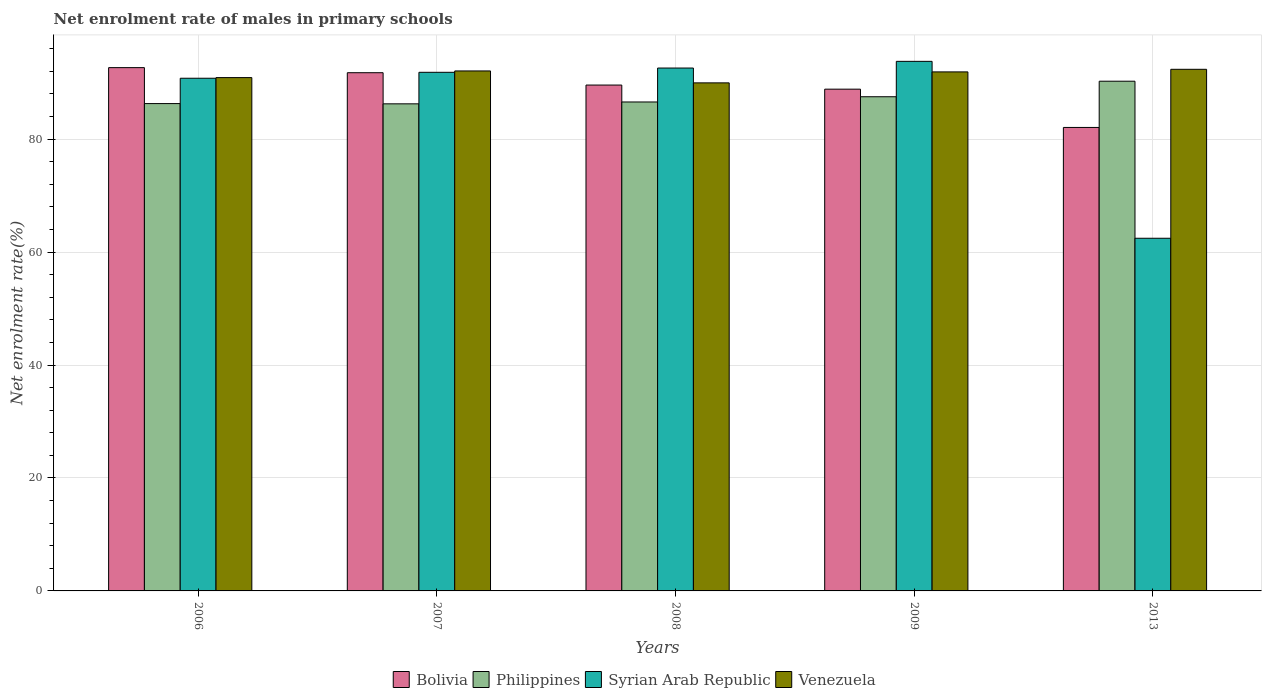How many different coloured bars are there?
Offer a very short reply. 4. How many bars are there on the 5th tick from the left?
Make the answer very short. 4. What is the net enrolment rate of males in primary schools in Bolivia in 2013?
Your answer should be compact. 82.07. Across all years, what is the maximum net enrolment rate of males in primary schools in Syrian Arab Republic?
Ensure brevity in your answer.  93.77. Across all years, what is the minimum net enrolment rate of males in primary schools in Bolivia?
Make the answer very short. 82.07. In which year was the net enrolment rate of males in primary schools in Syrian Arab Republic maximum?
Offer a terse response. 2009. In which year was the net enrolment rate of males in primary schools in Bolivia minimum?
Your response must be concise. 2013. What is the total net enrolment rate of males in primary schools in Philippines in the graph?
Provide a succinct answer. 436.88. What is the difference between the net enrolment rate of males in primary schools in Syrian Arab Republic in 2008 and that in 2013?
Your answer should be very brief. 30.14. What is the difference between the net enrolment rate of males in primary schools in Bolivia in 2006 and the net enrolment rate of males in primary schools in Philippines in 2013?
Give a very brief answer. 2.41. What is the average net enrolment rate of males in primary schools in Philippines per year?
Provide a succinct answer. 87.38. In the year 2006, what is the difference between the net enrolment rate of males in primary schools in Syrian Arab Republic and net enrolment rate of males in primary schools in Philippines?
Keep it short and to the point. 4.49. In how many years, is the net enrolment rate of males in primary schools in Philippines greater than 44 %?
Provide a succinct answer. 5. What is the ratio of the net enrolment rate of males in primary schools in Venezuela in 2006 to that in 2008?
Provide a succinct answer. 1.01. What is the difference between the highest and the second highest net enrolment rate of males in primary schools in Syrian Arab Republic?
Give a very brief answer. 1.18. What is the difference between the highest and the lowest net enrolment rate of males in primary schools in Syrian Arab Republic?
Offer a terse response. 31.32. In how many years, is the net enrolment rate of males in primary schools in Philippines greater than the average net enrolment rate of males in primary schools in Philippines taken over all years?
Your answer should be compact. 2. What does the 3rd bar from the left in 2007 represents?
Give a very brief answer. Syrian Arab Republic. What does the 3rd bar from the right in 2013 represents?
Your answer should be compact. Philippines. Is it the case that in every year, the sum of the net enrolment rate of males in primary schools in Philippines and net enrolment rate of males in primary schools in Venezuela is greater than the net enrolment rate of males in primary schools in Syrian Arab Republic?
Provide a succinct answer. Yes. How many bars are there?
Your answer should be compact. 20. Are all the bars in the graph horizontal?
Offer a very short reply. No. What is the difference between two consecutive major ticks on the Y-axis?
Provide a short and direct response. 20. Are the values on the major ticks of Y-axis written in scientific E-notation?
Give a very brief answer. No. Does the graph contain grids?
Make the answer very short. Yes. How many legend labels are there?
Offer a very short reply. 4. What is the title of the graph?
Make the answer very short. Net enrolment rate of males in primary schools. What is the label or title of the X-axis?
Make the answer very short. Years. What is the label or title of the Y-axis?
Give a very brief answer. Net enrolment rate(%). What is the Net enrolment rate(%) in Bolivia in 2006?
Your answer should be very brief. 92.66. What is the Net enrolment rate(%) of Philippines in 2006?
Your response must be concise. 86.29. What is the Net enrolment rate(%) in Syrian Arab Republic in 2006?
Ensure brevity in your answer.  90.78. What is the Net enrolment rate(%) of Venezuela in 2006?
Provide a short and direct response. 90.89. What is the Net enrolment rate(%) in Bolivia in 2007?
Provide a short and direct response. 91.76. What is the Net enrolment rate(%) in Philippines in 2007?
Your answer should be compact. 86.25. What is the Net enrolment rate(%) of Syrian Arab Republic in 2007?
Give a very brief answer. 91.83. What is the Net enrolment rate(%) of Venezuela in 2007?
Provide a short and direct response. 92.07. What is the Net enrolment rate(%) of Bolivia in 2008?
Keep it short and to the point. 89.57. What is the Net enrolment rate(%) of Philippines in 2008?
Give a very brief answer. 86.58. What is the Net enrolment rate(%) of Syrian Arab Republic in 2008?
Provide a short and direct response. 92.59. What is the Net enrolment rate(%) in Venezuela in 2008?
Your answer should be very brief. 89.96. What is the Net enrolment rate(%) in Bolivia in 2009?
Provide a succinct answer. 88.85. What is the Net enrolment rate(%) of Philippines in 2009?
Make the answer very short. 87.5. What is the Net enrolment rate(%) of Syrian Arab Republic in 2009?
Provide a succinct answer. 93.77. What is the Net enrolment rate(%) of Venezuela in 2009?
Your answer should be very brief. 91.9. What is the Net enrolment rate(%) of Bolivia in 2013?
Your answer should be very brief. 82.07. What is the Net enrolment rate(%) of Philippines in 2013?
Provide a succinct answer. 90.25. What is the Net enrolment rate(%) of Syrian Arab Republic in 2013?
Your answer should be compact. 62.45. What is the Net enrolment rate(%) in Venezuela in 2013?
Make the answer very short. 92.36. Across all years, what is the maximum Net enrolment rate(%) of Bolivia?
Make the answer very short. 92.66. Across all years, what is the maximum Net enrolment rate(%) in Philippines?
Make the answer very short. 90.25. Across all years, what is the maximum Net enrolment rate(%) in Syrian Arab Republic?
Provide a short and direct response. 93.77. Across all years, what is the maximum Net enrolment rate(%) of Venezuela?
Your response must be concise. 92.36. Across all years, what is the minimum Net enrolment rate(%) in Bolivia?
Make the answer very short. 82.07. Across all years, what is the minimum Net enrolment rate(%) in Philippines?
Your answer should be compact. 86.25. Across all years, what is the minimum Net enrolment rate(%) of Syrian Arab Republic?
Provide a short and direct response. 62.45. Across all years, what is the minimum Net enrolment rate(%) of Venezuela?
Your response must be concise. 89.96. What is the total Net enrolment rate(%) in Bolivia in the graph?
Provide a succinct answer. 444.9. What is the total Net enrolment rate(%) of Philippines in the graph?
Ensure brevity in your answer.  436.88. What is the total Net enrolment rate(%) of Syrian Arab Republic in the graph?
Ensure brevity in your answer.  431.42. What is the total Net enrolment rate(%) in Venezuela in the graph?
Ensure brevity in your answer.  457.19. What is the difference between the Net enrolment rate(%) in Bolivia in 2006 and that in 2007?
Offer a very short reply. 0.9. What is the difference between the Net enrolment rate(%) of Philippines in 2006 and that in 2007?
Your answer should be very brief. 0.04. What is the difference between the Net enrolment rate(%) in Syrian Arab Republic in 2006 and that in 2007?
Your answer should be compact. -1.05. What is the difference between the Net enrolment rate(%) in Venezuela in 2006 and that in 2007?
Offer a terse response. -1.18. What is the difference between the Net enrolment rate(%) of Bolivia in 2006 and that in 2008?
Make the answer very short. 3.08. What is the difference between the Net enrolment rate(%) in Philippines in 2006 and that in 2008?
Ensure brevity in your answer.  -0.29. What is the difference between the Net enrolment rate(%) of Syrian Arab Republic in 2006 and that in 2008?
Your answer should be very brief. -1.81. What is the difference between the Net enrolment rate(%) in Venezuela in 2006 and that in 2008?
Give a very brief answer. 0.93. What is the difference between the Net enrolment rate(%) in Bolivia in 2006 and that in 2009?
Provide a succinct answer. 3.81. What is the difference between the Net enrolment rate(%) in Philippines in 2006 and that in 2009?
Offer a terse response. -1.21. What is the difference between the Net enrolment rate(%) of Syrian Arab Republic in 2006 and that in 2009?
Provide a succinct answer. -2.99. What is the difference between the Net enrolment rate(%) of Venezuela in 2006 and that in 2009?
Your answer should be compact. -1.01. What is the difference between the Net enrolment rate(%) of Bolivia in 2006 and that in 2013?
Your answer should be very brief. 10.59. What is the difference between the Net enrolment rate(%) in Philippines in 2006 and that in 2013?
Your response must be concise. -3.96. What is the difference between the Net enrolment rate(%) of Syrian Arab Republic in 2006 and that in 2013?
Your answer should be compact. 28.33. What is the difference between the Net enrolment rate(%) in Venezuela in 2006 and that in 2013?
Offer a very short reply. -1.47. What is the difference between the Net enrolment rate(%) of Bolivia in 2007 and that in 2008?
Your response must be concise. 2.18. What is the difference between the Net enrolment rate(%) of Philippines in 2007 and that in 2008?
Provide a short and direct response. -0.33. What is the difference between the Net enrolment rate(%) in Syrian Arab Republic in 2007 and that in 2008?
Your response must be concise. -0.76. What is the difference between the Net enrolment rate(%) in Venezuela in 2007 and that in 2008?
Your response must be concise. 2.11. What is the difference between the Net enrolment rate(%) of Bolivia in 2007 and that in 2009?
Offer a very short reply. 2.91. What is the difference between the Net enrolment rate(%) of Philippines in 2007 and that in 2009?
Provide a short and direct response. -1.26. What is the difference between the Net enrolment rate(%) in Syrian Arab Republic in 2007 and that in 2009?
Your response must be concise. -1.94. What is the difference between the Net enrolment rate(%) of Venezuela in 2007 and that in 2009?
Offer a terse response. 0.17. What is the difference between the Net enrolment rate(%) in Bolivia in 2007 and that in 2013?
Your answer should be very brief. 9.69. What is the difference between the Net enrolment rate(%) in Philippines in 2007 and that in 2013?
Provide a succinct answer. -4. What is the difference between the Net enrolment rate(%) in Syrian Arab Republic in 2007 and that in 2013?
Ensure brevity in your answer.  29.39. What is the difference between the Net enrolment rate(%) of Venezuela in 2007 and that in 2013?
Keep it short and to the point. -0.29. What is the difference between the Net enrolment rate(%) in Bolivia in 2008 and that in 2009?
Ensure brevity in your answer.  0.73. What is the difference between the Net enrolment rate(%) of Philippines in 2008 and that in 2009?
Your answer should be compact. -0.93. What is the difference between the Net enrolment rate(%) of Syrian Arab Republic in 2008 and that in 2009?
Give a very brief answer. -1.18. What is the difference between the Net enrolment rate(%) in Venezuela in 2008 and that in 2009?
Offer a very short reply. -1.94. What is the difference between the Net enrolment rate(%) in Bolivia in 2008 and that in 2013?
Keep it short and to the point. 7.51. What is the difference between the Net enrolment rate(%) of Philippines in 2008 and that in 2013?
Make the answer very short. -3.68. What is the difference between the Net enrolment rate(%) in Syrian Arab Republic in 2008 and that in 2013?
Keep it short and to the point. 30.14. What is the difference between the Net enrolment rate(%) in Venezuela in 2008 and that in 2013?
Provide a succinct answer. -2.4. What is the difference between the Net enrolment rate(%) of Bolivia in 2009 and that in 2013?
Your answer should be very brief. 6.78. What is the difference between the Net enrolment rate(%) in Philippines in 2009 and that in 2013?
Ensure brevity in your answer.  -2.75. What is the difference between the Net enrolment rate(%) in Syrian Arab Republic in 2009 and that in 2013?
Provide a succinct answer. 31.32. What is the difference between the Net enrolment rate(%) of Venezuela in 2009 and that in 2013?
Your response must be concise. -0.46. What is the difference between the Net enrolment rate(%) of Bolivia in 2006 and the Net enrolment rate(%) of Philippines in 2007?
Your response must be concise. 6.41. What is the difference between the Net enrolment rate(%) in Bolivia in 2006 and the Net enrolment rate(%) in Syrian Arab Republic in 2007?
Your answer should be very brief. 0.83. What is the difference between the Net enrolment rate(%) in Bolivia in 2006 and the Net enrolment rate(%) in Venezuela in 2007?
Give a very brief answer. 0.59. What is the difference between the Net enrolment rate(%) of Philippines in 2006 and the Net enrolment rate(%) of Syrian Arab Republic in 2007?
Ensure brevity in your answer.  -5.54. What is the difference between the Net enrolment rate(%) of Philippines in 2006 and the Net enrolment rate(%) of Venezuela in 2007?
Offer a terse response. -5.78. What is the difference between the Net enrolment rate(%) of Syrian Arab Republic in 2006 and the Net enrolment rate(%) of Venezuela in 2007?
Provide a short and direct response. -1.29. What is the difference between the Net enrolment rate(%) in Bolivia in 2006 and the Net enrolment rate(%) in Philippines in 2008?
Your answer should be very brief. 6.08. What is the difference between the Net enrolment rate(%) in Bolivia in 2006 and the Net enrolment rate(%) in Syrian Arab Republic in 2008?
Your answer should be compact. 0.07. What is the difference between the Net enrolment rate(%) of Bolivia in 2006 and the Net enrolment rate(%) of Venezuela in 2008?
Provide a succinct answer. 2.7. What is the difference between the Net enrolment rate(%) of Philippines in 2006 and the Net enrolment rate(%) of Syrian Arab Republic in 2008?
Give a very brief answer. -6.3. What is the difference between the Net enrolment rate(%) of Philippines in 2006 and the Net enrolment rate(%) of Venezuela in 2008?
Your answer should be very brief. -3.67. What is the difference between the Net enrolment rate(%) in Syrian Arab Republic in 2006 and the Net enrolment rate(%) in Venezuela in 2008?
Ensure brevity in your answer.  0.82. What is the difference between the Net enrolment rate(%) of Bolivia in 2006 and the Net enrolment rate(%) of Philippines in 2009?
Your response must be concise. 5.15. What is the difference between the Net enrolment rate(%) of Bolivia in 2006 and the Net enrolment rate(%) of Syrian Arab Republic in 2009?
Provide a succinct answer. -1.11. What is the difference between the Net enrolment rate(%) of Bolivia in 2006 and the Net enrolment rate(%) of Venezuela in 2009?
Keep it short and to the point. 0.76. What is the difference between the Net enrolment rate(%) in Philippines in 2006 and the Net enrolment rate(%) in Syrian Arab Republic in 2009?
Give a very brief answer. -7.48. What is the difference between the Net enrolment rate(%) of Philippines in 2006 and the Net enrolment rate(%) of Venezuela in 2009?
Give a very brief answer. -5.61. What is the difference between the Net enrolment rate(%) of Syrian Arab Republic in 2006 and the Net enrolment rate(%) of Venezuela in 2009?
Ensure brevity in your answer.  -1.12. What is the difference between the Net enrolment rate(%) of Bolivia in 2006 and the Net enrolment rate(%) of Philippines in 2013?
Your answer should be very brief. 2.41. What is the difference between the Net enrolment rate(%) of Bolivia in 2006 and the Net enrolment rate(%) of Syrian Arab Republic in 2013?
Make the answer very short. 30.21. What is the difference between the Net enrolment rate(%) in Bolivia in 2006 and the Net enrolment rate(%) in Venezuela in 2013?
Your answer should be very brief. 0.29. What is the difference between the Net enrolment rate(%) in Philippines in 2006 and the Net enrolment rate(%) in Syrian Arab Republic in 2013?
Ensure brevity in your answer.  23.85. What is the difference between the Net enrolment rate(%) of Philippines in 2006 and the Net enrolment rate(%) of Venezuela in 2013?
Provide a short and direct response. -6.07. What is the difference between the Net enrolment rate(%) in Syrian Arab Republic in 2006 and the Net enrolment rate(%) in Venezuela in 2013?
Offer a very short reply. -1.58. What is the difference between the Net enrolment rate(%) in Bolivia in 2007 and the Net enrolment rate(%) in Philippines in 2008?
Provide a succinct answer. 5.18. What is the difference between the Net enrolment rate(%) of Bolivia in 2007 and the Net enrolment rate(%) of Syrian Arab Republic in 2008?
Offer a very short reply. -0.83. What is the difference between the Net enrolment rate(%) in Bolivia in 2007 and the Net enrolment rate(%) in Venezuela in 2008?
Offer a very short reply. 1.8. What is the difference between the Net enrolment rate(%) in Philippines in 2007 and the Net enrolment rate(%) in Syrian Arab Republic in 2008?
Keep it short and to the point. -6.34. What is the difference between the Net enrolment rate(%) in Philippines in 2007 and the Net enrolment rate(%) in Venezuela in 2008?
Make the answer very short. -3.71. What is the difference between the Net enrolment rate(%) of Syrian Arab Republic in 2007 and the Net enrolment rate(%) of Venezuela in 2008?
Provide a short and direct response. 1.87. What is the difference between the Net enrolment rate(%) of Bolivia in 2007 and the Net enrolment rate(%) of Philippines in 2009?
Keep it short and to the point. 4.25. What is the difference between the Net enrolment rate(%) in Bolivia in 2007 and the Net enrolment rate(%) in Syrian Arab Republic in 2009?
Give a very brief answer. -2.01. What is the difference between the Net enrolment rate(%) in Bolivia in 2007 and the Net enrolment rate(%) in Venezuela in 2009?
Provide a succinct answer. -0.14. What is the difference between the Net enrolment rate(%) of Philippines in 2007 and the Net enrolment rate(%) of Syrian Arab Republic in 2009?
Provide a short and direct response. -7.52. What is the difference between the Net enrolment rate(%) in Philippines in 2007 and the Net enrolment rate(%) in Venezuela in 2009?
Give a very brief answer. -5.65. What is the difference between the Net enrolment rate(%) of Syrian Arab Republic in 2007 and the Net enrolment rate(%) of Venezuela in 2009?
Give a very brief answer. -0.07. What is the difference between the Net enrolment rate(%) in Bolivia in 2007 and the Net enrolment rate(%) in Philippines in 2013?
Offer a terse response. 1.51. What is the difference between the Net enrolment rate(%) of Bolivia in 2007 and the Net enrolment rate(%) of Syrian Arab Republic in 2013?
Offer a very short reply. 29.31. What is the difference between the Net enrolment rate(%) in Bolivia in 2007 and the Net enrolment rate(%) in Venezuela in 2013?
Your answer should be very brief. -0.6. What is the difference between the Net enrolment rate(%) in Philippines in 2007 and the Net enrolment rate(%) in Syrian Arab Republic in 2013?
Your answer should be compact. 23.8. What is the difference between the Net enrolment rate(%) in Philippines in 2007 and the Net enrolment rate(%) in Venezuela in 2013?
Give a very brief answer. -6.11. What is the difference between the Net enrolment rate(%) in Syrian Arab Republic in 2007 and the Net enrolment rate(%) in Venezuela in 2013?
Offer a terse response. -0.53. What is the difference between the Net enrolment rate(%) in Bolivia in 2008 and the Net enrolment rate(%) in Philippines in 2009?
Provide a short and direct response. 2.07. What is the difference between the Net enrolment rate(%) of Bolivia in 2008 and the Net enrolment rate(%) of Syrian Arab Republic in 2009?
Keep it short and to the point. -4.2. What is the difference between the Net enrolment rate(%) in Bolivia in 2008 and the Net enrolment rate(%) in Venezuela in 2009?
Make the answer very short. -2.33. What is the difference between the Net enrolment rate(%) of Philippines in 2008 and the Net enrolment rate(%) of Syrian Arab Republic in 2009?
Your answer should be very brief. -7.19. What is the difference between the Net enrolment rate(%) of Philippines in 2008 and the Net enrolment rate(%) of Venezuela in 2009?
Give a very brief answer. -5.33. What is the difference between the Net enrolment rate(%) in Syrian Arab Republic in 2008 and the Net enrolment rate(%) in Venezuela in 2009?
Make the answer very short. 0.69. What is the difference between the Net enrolment rate(%) in Bolivia in 2008 and the Net enrolment rate(%) in Philippines in 2013?
Offer a very short reply. -0.68. What is the difference between the Net enrolment rate(%) in Bolivia in 2008 and the Net enrolment rate(%) in Syrian Arab Republic in 2013?
Offer a terse response. 27.13. What is the difference between the Net enrolment rate(%) in Bolivia in 2008 and the Net enrolment rate(%) in Venezuela in 2013?
Give a very brief answer. -2.79. What is the difference between the Net enrolment rate(%) in Philippines in 2008 and the Net enrolment rate(%) in Syrian Arab Republic in 2013?
Offer a terse response. 24.13. What is the difference between the Net enrolment rate(%) in Philippines in 2008 and the Net enrolment rate(%) in Venezuela in 2013?
Make the answer very short. -5.79. What is the difference between the Net enrolment rate(%) of Syrian Arab Republic in 2008 and the Net enrolment rate(%) of Venezuela in 2013?
Provide a succinct answer. 0.22. What is the difference between the Net enrolment rate(%) of Bolivia in 2009 and the Net enrolment rate(%) of Philippines in 2013?
Keep it short and to the point. -1.41. What is the difference between the Net enrolment rate(%) of Bolivia in 2009 and the Net enrolment rate(%) of Syrian Arab Republic in 2013?
Make the answer very short. 26.4. What is the difference between the Net enrolment rate(%) of Bolivia in 2009 and the Net enrolment rate(%) of Venezuela in 2013?
Offer a terse response. -3.52. What is the difference between the Net enrolment rate(%) of Philippines in 2009 and the Net enrolment rate(%) of Syrian Arab Republic in 2013?
Your response must be concise. 25.06. What is the difference between the Net enrolment rate(%) of Philippines in 2009 and the Net enrolment rate(%) of Venezuela in 2013?
Give a very brief answer. -4.86. What is the difference between the Net enrolment rate(%) in Syrian Arab Republic in 2009 and the Net enrolment rate(%) in Venezuela in 2013?
Provide a short and direct response. 1.41. What is the average Net enrolment rate(%) of Bolivia per year?
Your answer should be compact. 88.98. What is the average Net enrolment rate(%) in Philippines per year?
Make the answer very short. 87.38. What is the average Net enrolment rate(%) in Syrian Arab Republic per year?
Ensure brevity in your answer.  86.28. What is the average Net enrolment rate(%) of Venezuela per year?
Provide a succinct answer. 91.44. In the year 2006, what is the difference between the Net enrolment rate(%) of Bolivia and Net enrolment rate(%) of Philippines?
Provide a succinct answer. 6.37. In the year 2006, what is the difference between the Net enrolment rate(%) in Bolivia and Net enrolment rate(%) in Syrian Arab Republic?
Your answer should be very brief. 1.88. In the year 2006, what is the difference between the Net enrolment rate(%) of Bolivia and Net enrolment rate(%) of Venezuela?
Ensure brevity in your answer.  1.76. In the year 2006, what is the difference between the Net enrolment rate(%) of Philippines and Net enrolment rate(%) of Syrian Arab Republic?
Provide a succinct answer. -4.49. In the year 2006, what is the difference between the Net enrolment rate(%) of Philippines and Net enrolment rate(%) of Venezuela?
Your answer should be very brief. -4.6. In the year 2006, what is the difference between the Net enrolment rate(%) in Syrian Arab Republic and Net enrolment rate(%) in Venezuela?
Your answer should be compact. -0.11. In the year 2007, what is the difference between the Net enrolment rate(%) of Bolivia and Net enrolment rate(%) of Philippines?
Provide a succinct answer. 5.51. In the year 2007, what is the difference between the Net enrolment rate(%) of Bolivia and Net enrolment rate(%) of Syrian Arab Republic?
Make the answer very short. -0.07. In the year 2007, what is the difference between the Net enrolment rate(%) in Bolivia and Net enrolment rate(%) in Venezuela?
Offer a very short reply. -0.31. In the year 2007, what is the difference between the Net enrolment rate(%) in Philippines and Net enrolment rate(%) in Syrian Arab Republic?
Provide a short and direct response. -5.58. In the year 2007, what is the difference between the Net enrolment rate(%) in Philippines and Net enrolment rate(%) in Venezuela?
Your answer should be compact. -5.82. In the year 2007, what is the difference between the Net enrolment rate(%) in Syrian Arab Republic and Net enrolment rate(%) in Venezuela?
Your answer should be very brief. -0.24. In the year 2008, what is the difference between the Net enrolment rate(%) in Bolivia and Net enrolment rate(%) in Philippines?
Your response must be concise. 3. In the year 2008, what is the difference between the Net enrolment rate(%) of Bolivia and Net enrolment rate(%) of Syrian Arab Republic?
Provide a short and direct response. -3.01. In the year 2008, what is the difference between the Net enrolment rate(%) in Bolivia and Net enrolment rate(%) in Venezuela?
Your answer should be compact. -0.39. In the year 2008, what is the difference between the Net enrolment rate(%) of Philippines and Net enrolment rate(%) of Syrian Arab Republic?
Your answer should be very brief. -6.01. In the year 2008, what is the difference between the Net enrolment rate(%) in Philippines and Net enrolment rate(%) in Venezuela?
Offer a terse response. -3.38. In the year 2008, what is the difference between the Net enrolment rate(%) in Syrian Arab Republic and Net enrolment rate(%) in Venezuela?
Make the answer very short. 2.63. In the year 2009, what is the difference between the Net enrolment rate(%) of Bolivia and Net enrolment rate(%) of Philippines?
Your response must be concise. 1.34. In the year 2009, what is the difference between the Net enrolment rate(%) of Bolivia and Net enrolment rate(%) of Syrian Arab Republic?
Ensure brevity in your answer.  -4.92. In the year 2009, what is the difference between the Net enrolment rate(%) of Bolivia and Net enrolment rate(%) of Venezuela?
Provide a short and direct response. -3.06. In the year 2009, what is the difference between the Net enrolment rate(%) in Philippines and Net enrolment rate(%) in Syrian Arab Republic?
Your answer should be compact. -6.27. In the year 2009, what is the difference between the Net enrolment rate(%) of Philippines and Net enrolment rate(%) of Venezuela?
Make the answer very short. -4.4. In the year 2009, what is the difference between the Net enrolment rate(%) of Syrian Arab Republic and Net enrolment rate(%) of Venezuela?
Your answer should be compact. 1.87. In the year 2013, what is the difference between the Net enrolment rate(%) in Bolivia and Net enrolment rate(%) in Philippines?
Offer a terse response. -8.19. In the year 2013, what is the difference between the Net enrolment rate(%) of Bolivia and Net enrolment rate(%) of Syrian Arab Republic?
Give a very brief answer. 19.62. In the year 2013, what is the difference between the Net enrolment rate(%) of Bolivia and Net enrolment rate(%) of Venezuela?
Keep it short and to the point. -10.3. In the year 2013, what is the difference between the Net enrolment rate(%) in Philippines and Net enrolment rate(%) in Syrian Arab Republic?
Ensure brevity in your answer.  27.81. In the year 2013, what is the difference between the Net enrolment rate(%) in Philippines and Net enrolment rate(%) in Venezuela?
Provide a succinct answer. -2.11. In the year 2013, what is the difference between the Net enrolment rate(%) of Syrian Arab Republic and Net enrolment rate(%) of Venezuela?
Give a very brief answer. -29.92. What is the ratio of the Net enrolment rate(%) in Bolivia in 2006 to that in 2007?
Offer a very short reply. 1.01. What is the ratio of the Net enrolment rate(%) of Philippines in 2006 to that in 2007?
Your answer should be very brief. 1. What is the ratio of the Net enrolment rate(%) of Syrian Arab Republic in 2006 to that in 2007?
Provide a short and direct response. 0.99. What is the ratio of the Net enrolment rate(%) of Venezuela in 2006 to that in 2007?
Offer a very short reply. 0.99. What is the ratio of the Net enrolment rate(%) in Bolivia in 2006 to that in 2008?
Ensure brevity in your answer.  1.03. What is the ratio of the Net enrolment rate(%) in Syrian Arab Republic in 2006 to that in 2008?
Your answer should be very brief. 0.98. What is the ratio of the Net enrolment rate(%) in Venezuela in 2006 to that in 2008?
Provide a short and direct response. 1.01. What is the ratio of the Net enrolment rate(%) of Bolivia in 2006 to that in 2009?
Your response must be concise. 1.04. What is the ratio of the Net enrolment rate(%) in Philippines in 2006 to that in 2009?
Give a very brief answer. 0.99. What is the ratio of the Net enrolment rate(%) of Syrian Arab Republic in 2006 to that in 2009?
Ensure brevity in your answer.  0.97. What is the ratio of the Net enrolment rate(%) in Bolivia in 2006 to that in 2013?
Make the answer very short. 1.13. What is the ratio of the Net enrolment rate(%) in Philippines in 2006 to that in 2013?
Provide a succinct answer. 0.96. What is the ratio of the Net enrolment rate(%) in Syrian Arab Republic in 2006 to that in 2013?
Make the answer very short. 1.45. What is the ratio of the Net enrolment rate(%) of Venezuela in 2006 to that in 2013?
Offer a very short reply. 0.98. What is the ratio of the Net enrolment rate(%) in Bolivia in 2007 to that in 2008?
Offer a terse response. 1.02. What is the ratio of the Net enrolment rate(%) in Venezuela in 2007 to that in 2008?
Make the answer very short. 1.02. What is the ratio of the Net enrolment rate(%) in Bolivia in 2007 to that in 2009?
Your response must be concise. 1.03. What is the ratio of the Net enrolment rate(%) of Philippines in 2007 to that in 2009?
Keep it short and to the point. 0.99. What is the ratio of the Net enrolment rate(%) of Syrian Arab Republic in 2007 to that in 2009?
Your answer should be compact. 0.98. What is the ratio of the Net enrolment rate(%) in Venezuela in 2007 to that in 2009?
Offer a very short reply. 1. What is the ratio of the Net enrolment rate(%) of Bolivia in 2007 to that in 2013?
Provide a short and direct response. 1.12. What is the ratio of the Net enrolment rate(%) of Philippines in 2007 to that in 2013?
Your answer should be very brief. 0.96. What is the ratio of the Net enrolment rate(%) of Syrian Arab Republic in 2007 to that in 2013?
Ensure brevity in your answer.  1.47. What is the ratio of the Net enrolment rate(%) of Venezuela in 2007 to that in 2013?
Your response must be concise. 1. What is the ratio of the Net enrolment rate(%) of Bolivia in 2008 to that in 2009?
Ensure brevity in your answer.  1.01. What is the ratio of the Net enrolment rate(%) in Syrian Arab Republic in 2008 to that in 2009?
Ensure brevity in your answer.  0.99. What is the ratio of the Net enrolment rate(%) of Venezuela in 2008 to that in 2009?
Give a very brief answer. 0.98. What is the ratio of the Net enrolment rate(%) of Bolivia in 2008 to that in 2013?
Make the answer very short. 1.09. What is the ratio of the Net enrolment rate(%) of Philippines in 2008 to that in 2013?
Your response must be concise. 0.96. What is the ratio of the Net enrolment rate(%) of Syrian Arab Republic in 2008 to that in 2013?
Keep it short and to the point. 1.48. What is the ratio of the Net enrolment rate(%) in Venezuela in 2008 to that in 2013?
Keep it short and to the point. 0.97. What is the ratio of the Net enrolment rate(%) in Bolivia in 2009 to that in 2013?
Offer a terse response. 1.08. What is the ratio of the Net enrolment rate(%) in Philippines in 2009 to that in 2013?
Offer a very short reply. 0.97. What is the ratio of the Net enrolment rate(%) in Syrian Arab Republic in 2009 to that in 2013?
Keep it short and to the point. 1.5. What is the ratio of the Net enrolment rate(%) in Venezuela in 2009 to that in 2013?
Offer a very short reply. 0.99. What is the difference between the highest and the second highest Net enrolment rate(%) in Bolivia?
Give a very brief answer. 0.9. What is the difference between the highest and the second highest Net enrolment rate(%) in Philippines?
Give a very brief answer. 2.75. What is the difference between the highest and the second highest Net enrolment rate(%) of Syrian Arab Republic?
Provide a succinct answer. 1.18. What is the difference between the highest and the second highest Net enrolment rate(%) in Venezuela?
Offer a very short reply. 0.29. What is the difference between the highest and the lowest Net enrolment rate(%) in Bolivia?
Provide a succinct answer. 10.59. What is the difference between the highest and the lowest Net enrolment rate(%) in Philippines?
Provide a short and direct response. 4. What is the difference between the highest and the lowest Net enrolment rate(%) of Syrian Arab Republic?
Your response must be concise. 31.32. What is the difference between the highest and the lowest Net enrolment rate(%) in Venezuela?
Provide a succinct answer. 2.4. 